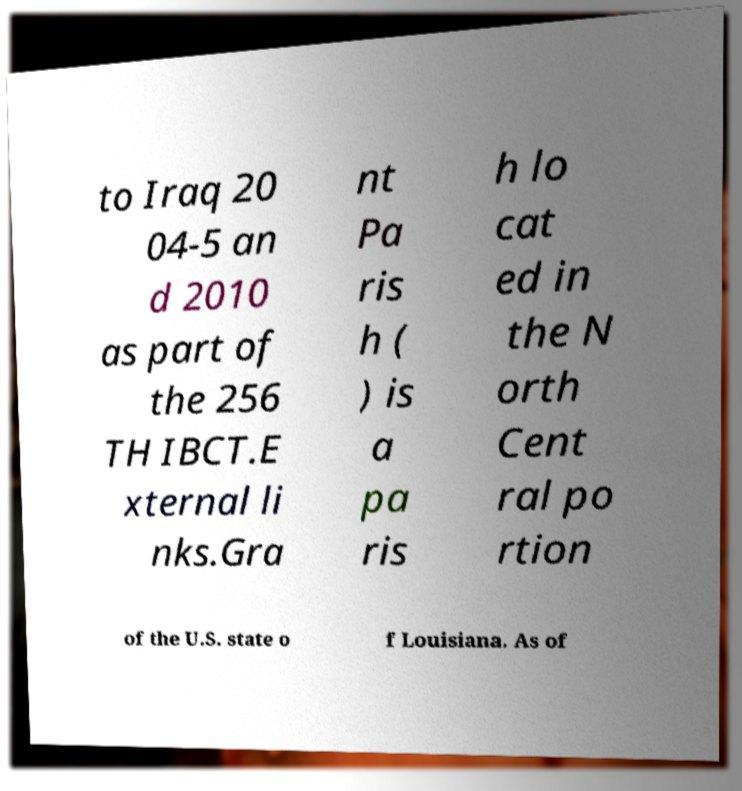Could you extract and type out the text from this image? to Iraq 20 04-5 an d 2010 as part of the 256 TH IBCT.E xternal li nks.Gra nt Pa ris h ( ) is a pa ris h lo cat ed in the N orth Cent ral po rtion of the U.S. state o f Louisiana. As of 